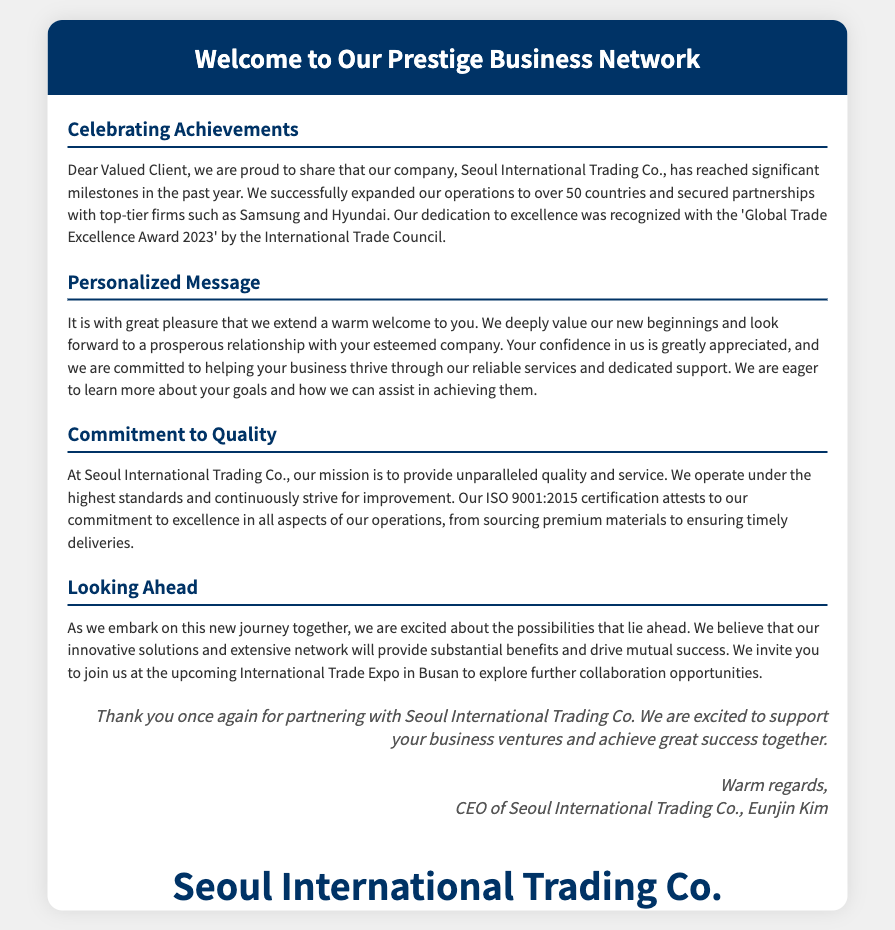What is the name of the company? The name of the company is stated clearly in the document.
Answer: Seoul International Trading Co How many countries has the company expanded to? The document specifies the number of countries in which the company has expanded its operations.
Answer: 50 What award did the company receive? The specific award recognized by the International Trade Council is mentioned in the document.
Answer: Global Trade Excellence Award 2023 Who is the CEO of the company? The document contains the name of the CEO mentioned in the closing section.
Answer: Eunjin Kim What is the company’s certification? The type of certification that attests to the company's commitment to quality is noted in the document.
Answer: ISO 9001:2015 What event is the company inviting clients to? The document refers to an event where collaboration opportunities can be explored.
Answer: International Trade Expo in Busan What is the main mission of the company? The company's mission regarding quality and service is stated in the document.
Answer: Provide unparalleled quality and service What is emphasized about the company’s service commitment? The document highlights a specific aspect of the company's operations commitment.
Answer: Highest standards and continuous improvement What type of card is this document? The nature of the document is indicated by its title and content structure.
Answer: Greeting card 